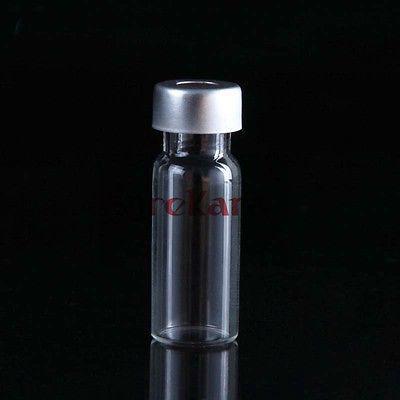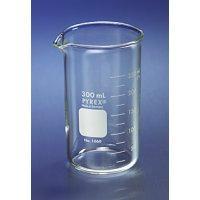The first image is the image on the left, the second image is the image on the right. Analyze the images presented: Is the assertion "An image contains just one beaker, which is cylinder shaped." valid? Answer yes or no. Yes. The first image is the image on the left, the second image is the image on the right. Given the left and right images, does the statement "One or more beakers in one image are partially filled with colored liquid, while the one beaker in the other image is triangular shaped and empty." hold true? Answer yes or no. No. 